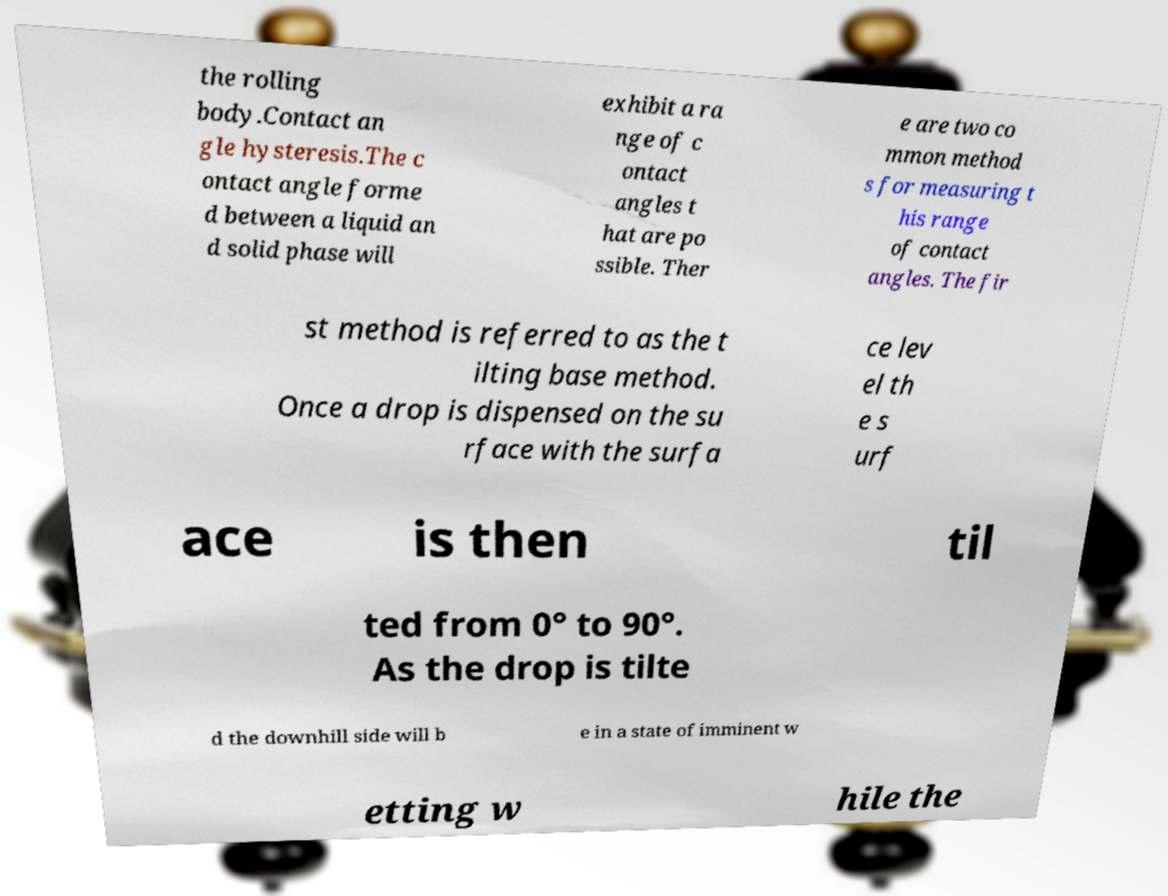For documentation purposes, I need the text within this image transcribed. Could you provide that? the rolling body.Contact an gle hysteresis.The c ontact angle forme d between a liquid an d solid phase will exhibit a ra nge of c ontact angles t hat are po ssible. Ther e are two co mmon method s for measuring t his range of contact angles. The fir st method is referred to as the t ilting base method. Once a drop is dispensed on the su rface with the surfa ce lev el th e s urf ace is then til ted from 0° to 90°. As the drop is tilte d the downhill side will b e in a state of imminent w etting w hile the 